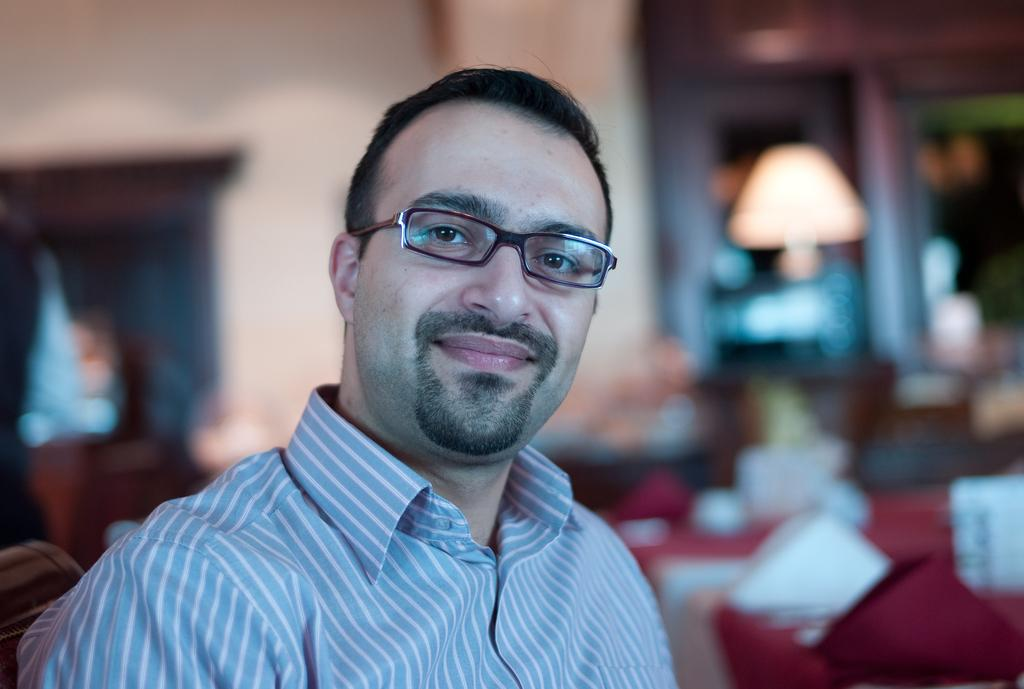What is present in the image? There is a person in the image. Can you describe the person's clothing? The person is wearing a shirt. What accessory is the person wearing? The person is wearing spectacles. What expression does the person have? The person is smiling. How would you describe the background of the image? The background of the image is blurred. Can you tell me how many tomatoes are on the rod in the image? There are no tomatoes or rods present in the image. Is there a harbor visible in the background of the image? There is no harbor visible in the image; the background is blurred. 